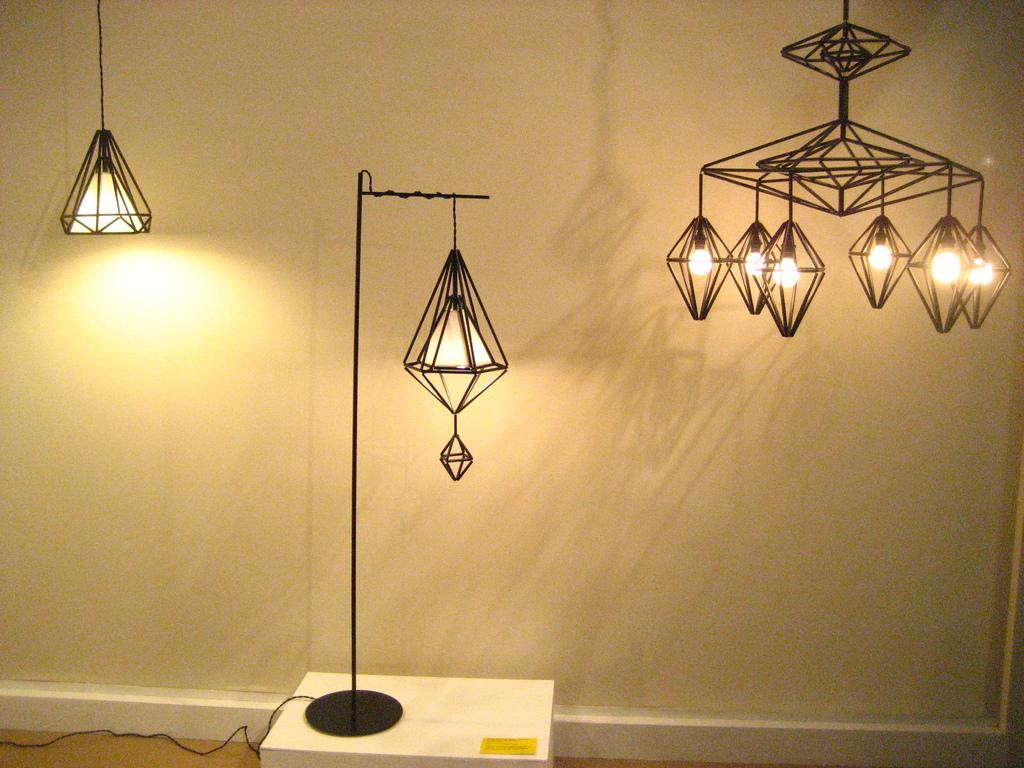What is the main object in the center of the image? There is a lamp with a stand on a box in the center of the image. Can you describe the other lighting fixtures in the image? There is another lamp at the top side of the image and a chandelier on the right side of the image. What else can be seen at the bottom side of the image? There is a wire at the bottom side of the image. Who is helping the lamp on the right side of the image? There is no person present in the image to help the lamp; it is a stationary object. 